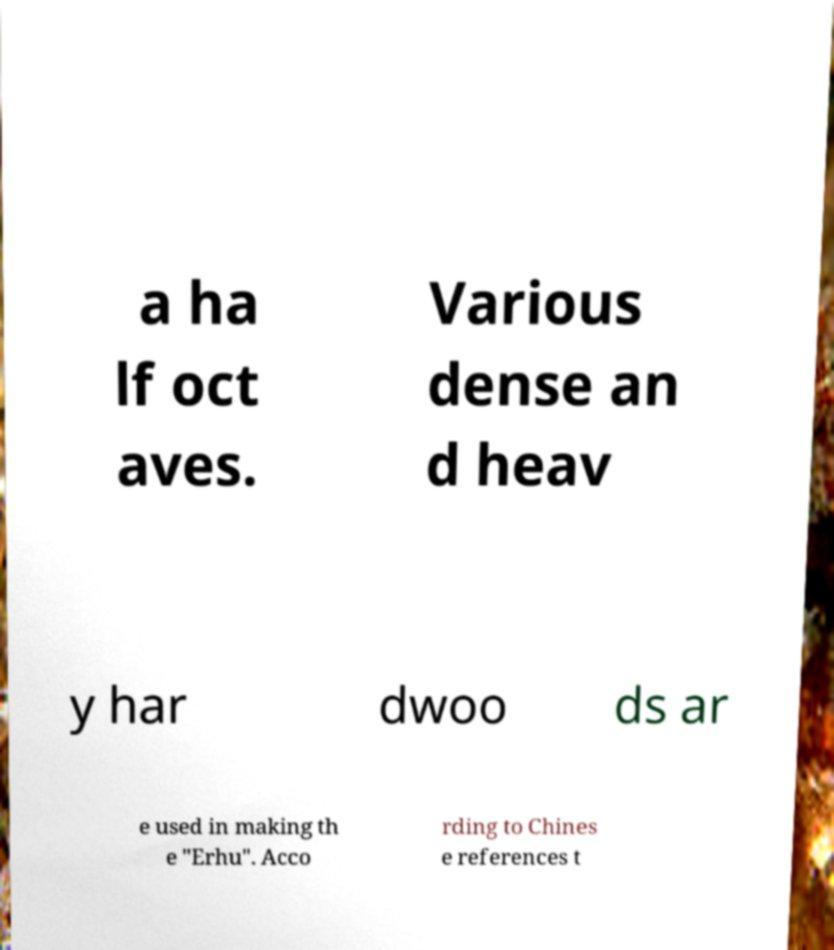For documentation purposes, I need the text within this image transcribed. Could you provide that? a ha lf oct aves. Various dense an d heav y har dwoo ds ar e used in making th e "Erhu". Acco rding to Chines e references t 